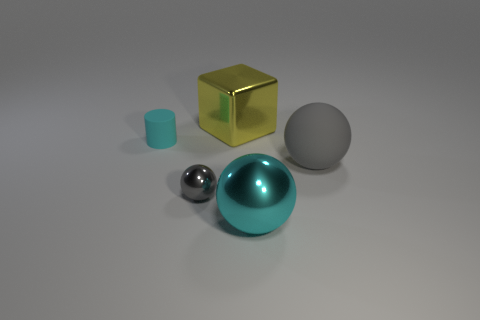Subtract all small gray shiny spheres. How many spheres are left? 2 Subtract all yellow cylinders. How many gray spheres are left? 2 Add 1 big cubes. How many objects exist? 6 Subtract all cylinders. How many objects are left? 4 Subtract all red balls. Subtract all green blocks. How many balls are left? 3 Subtract all small yellow rubber things. Subtract all large cyan metallic objects. How many objects are left? 4 Add 2 large matte balls. How many large matte balls are left? 3 Add 1 matte things. How many matte things exist? 3 Subtract 0 blue cubes. How many objects are left? 5 